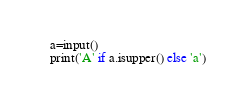Convert code to text. <code><loc_0><loc_0><loc_500><loc_500><_Python_>a=input()
print('A' if a.isupper() else 'a')</code> 